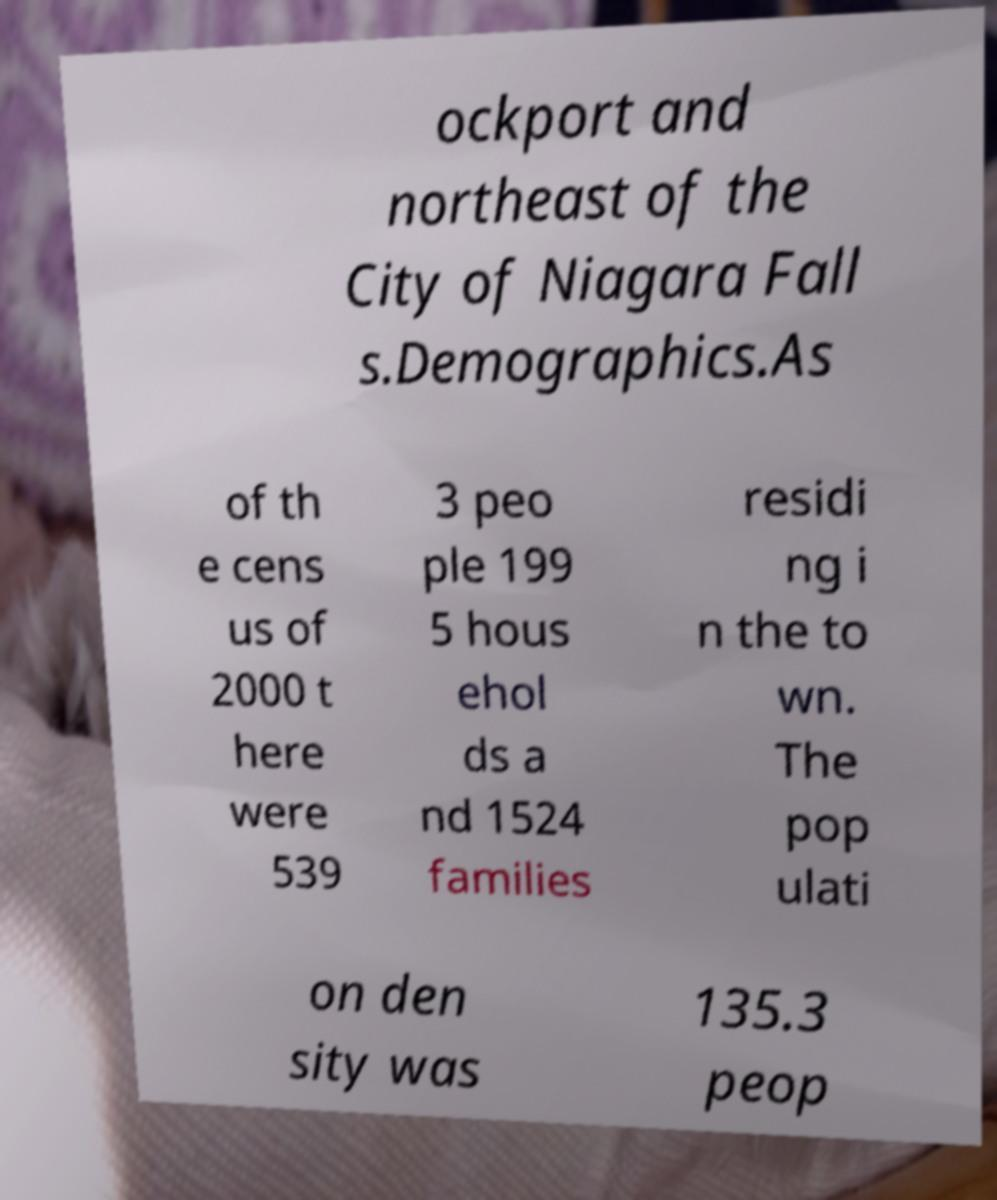Could you extract and type out the text from this image? ockport and northeast of the City of Niagara Fall s.Demographics.As of th e cens us of 2000 t here were 539 3 peo ple 199 5 hous ehol ds a nd 1524 families residi ng i n the to wn. The pop ulati on den sity was 135.3 peop 